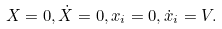Convert formula to latex. <formula><loc_0><loc_0><loc_500><loc_500>X = 0 , \dot { X } = 0 , x _ { i } = 0 , \dot { x } _ { i } = V .</formula> 